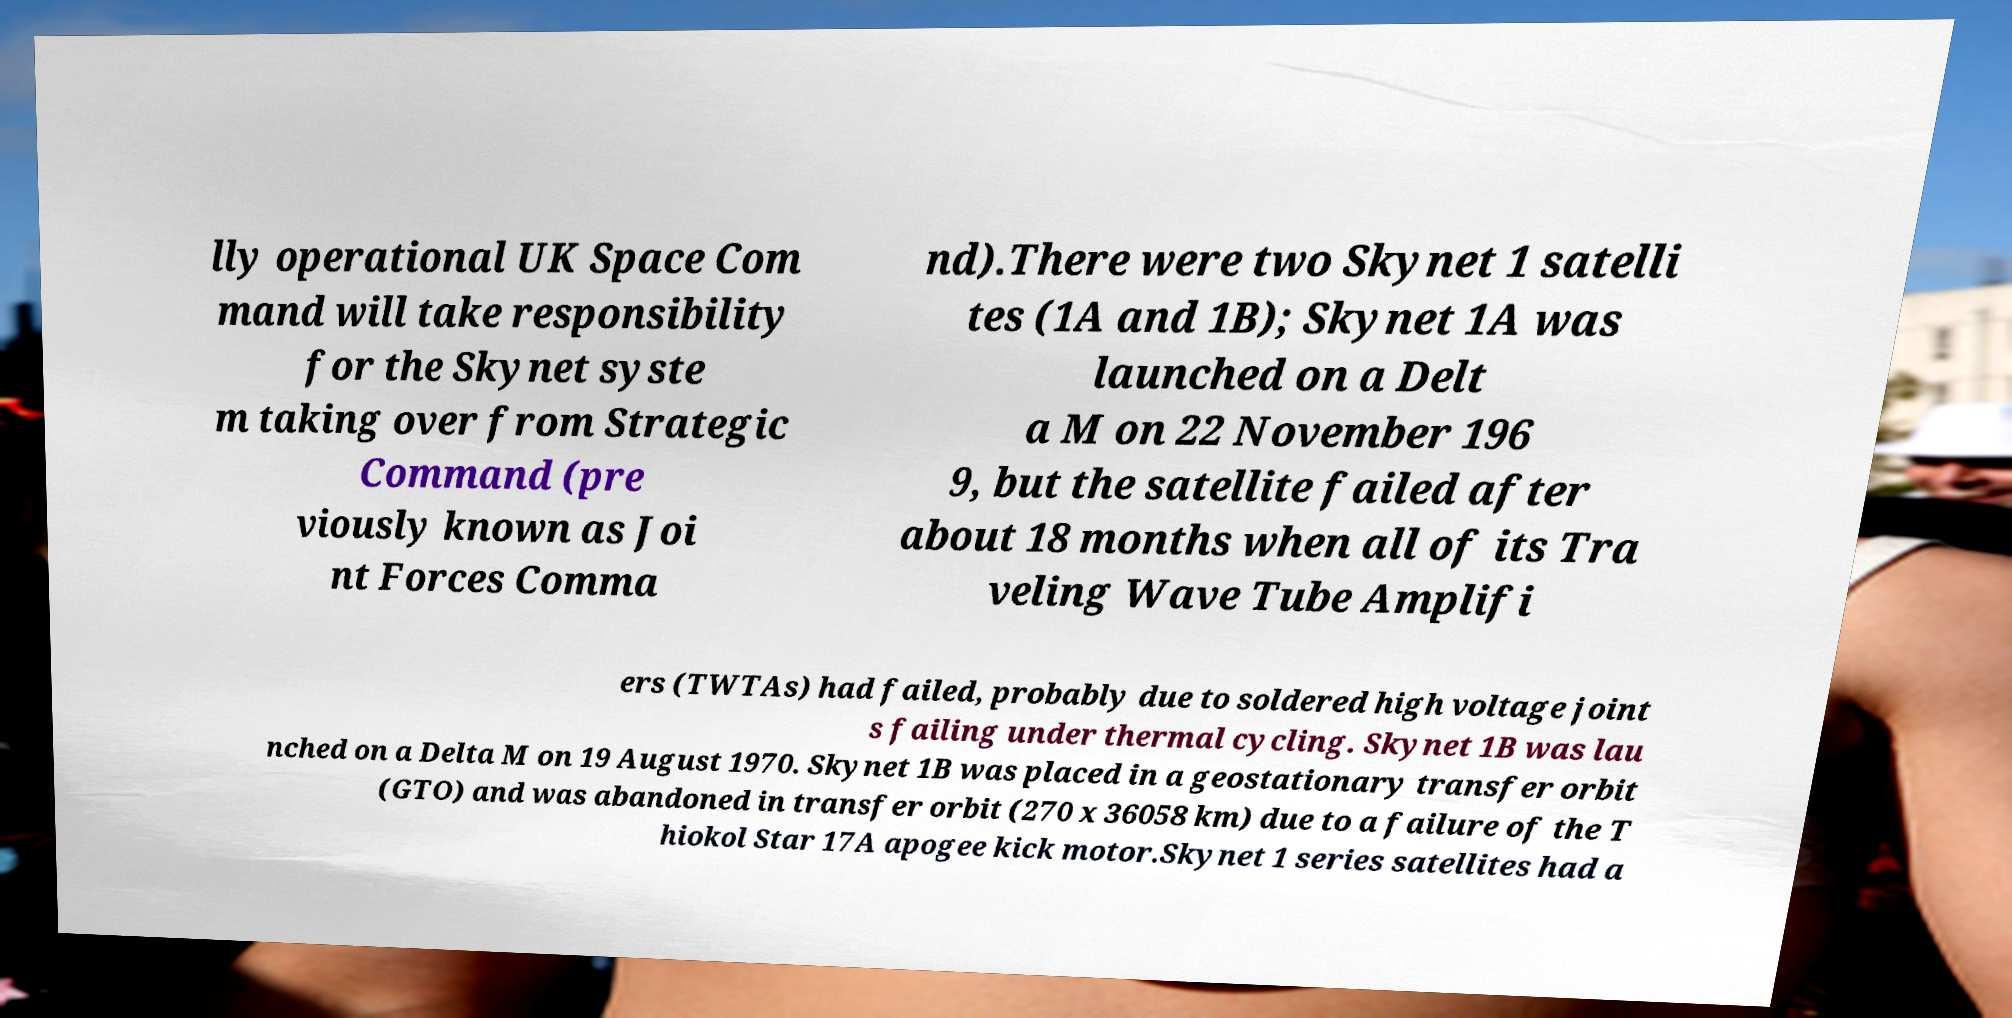For documentation purposes, I need the text within this image transcribed. Could you provide that? lly operational UK Space Com mand will take responsibility for the Skynet syste m taking over from Strategic Command (pre viously known as Joi nt Forces Comma nd).There were two Skynet 1 satelli tes (1A and 1B); Skynet 1A was launched on a Delt a M on 22 November 196 9, but the satellite failed after about 18 months when all of its Tra veling Wave Tube Amplifi ers (TWTAs) had failed, probably due to soldered high voltage joint s failing under thermal cycling. Skynet 1B was lau nched on a Delta M on 19 August 1970. Skynet 1B was placed in a geostationary transfer orbit (GTO) and was abandoned in transfer orbit (270 x 36058 km) due to a failure of the T hiokol Star 17A apogee kick motor.Skynet 1 series satellites had a 